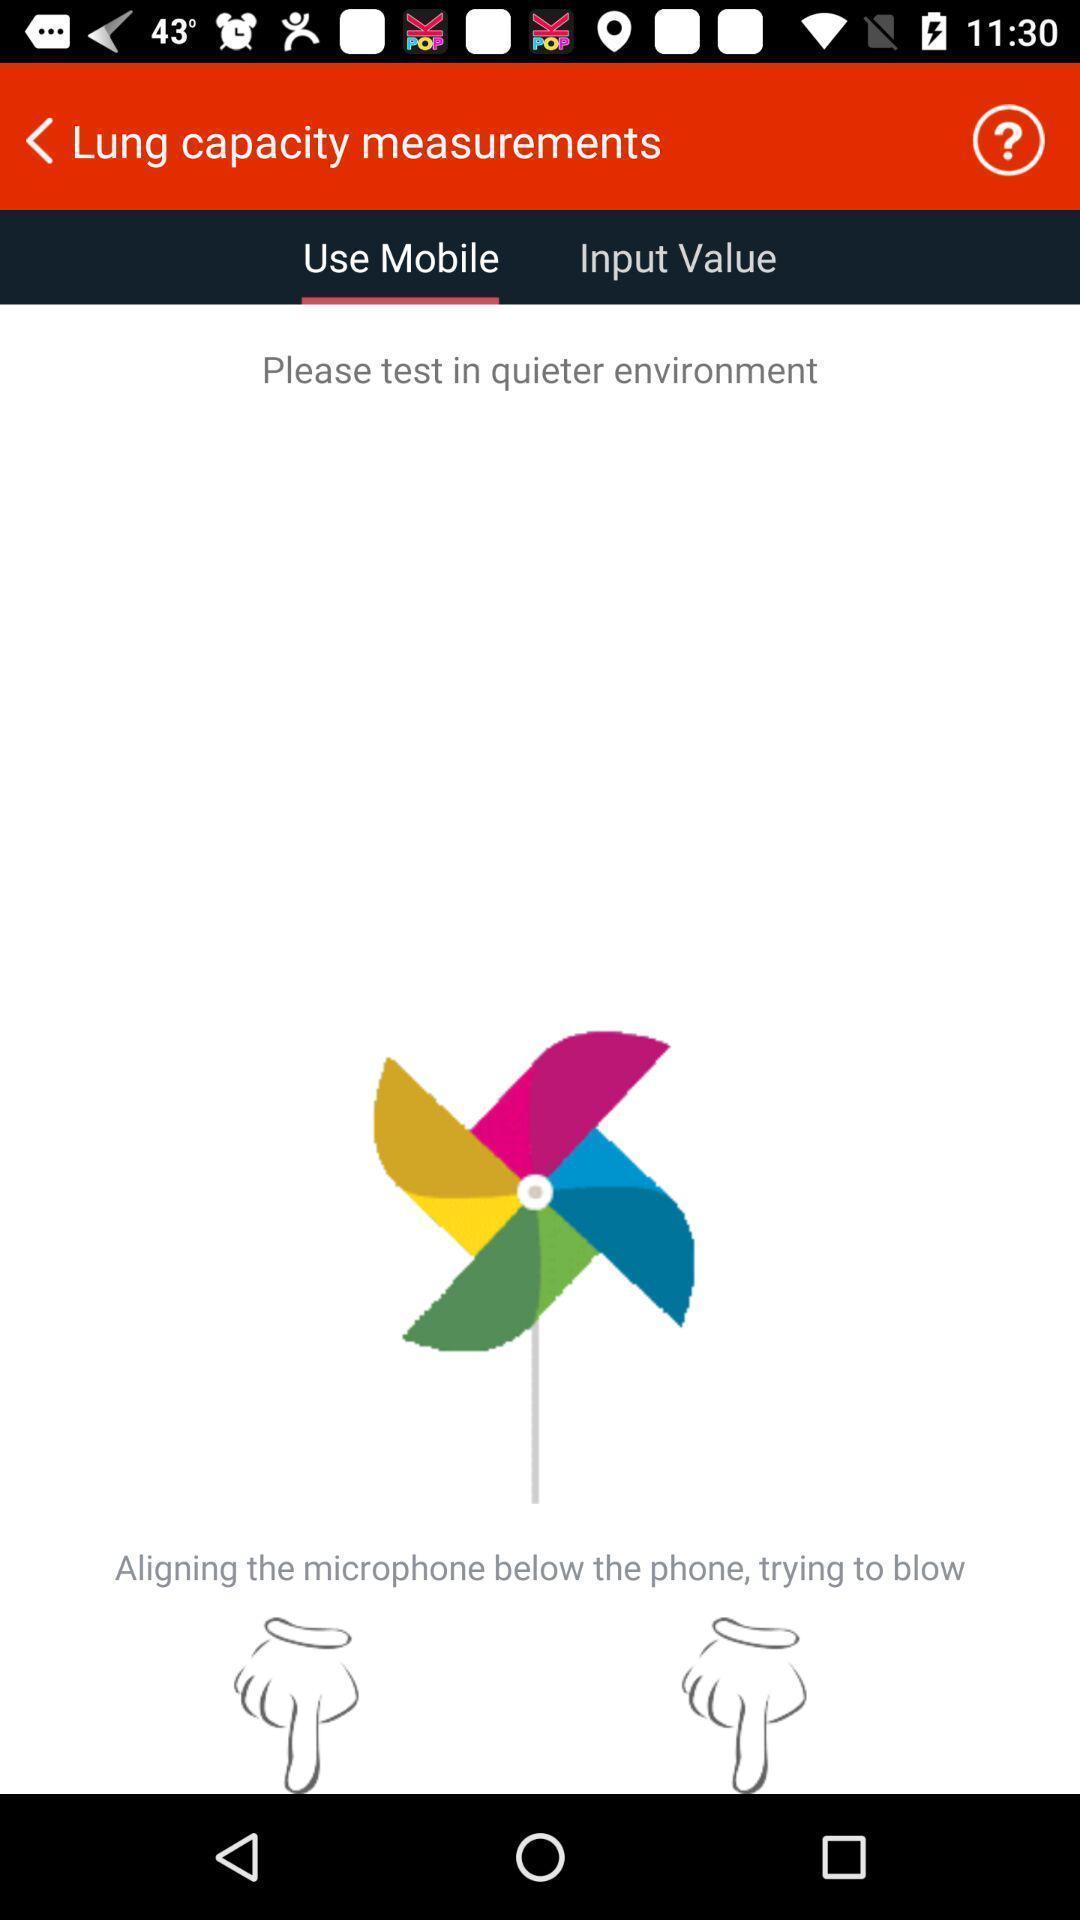Please provide a description for this image. Welcome page displaying of an health application. 